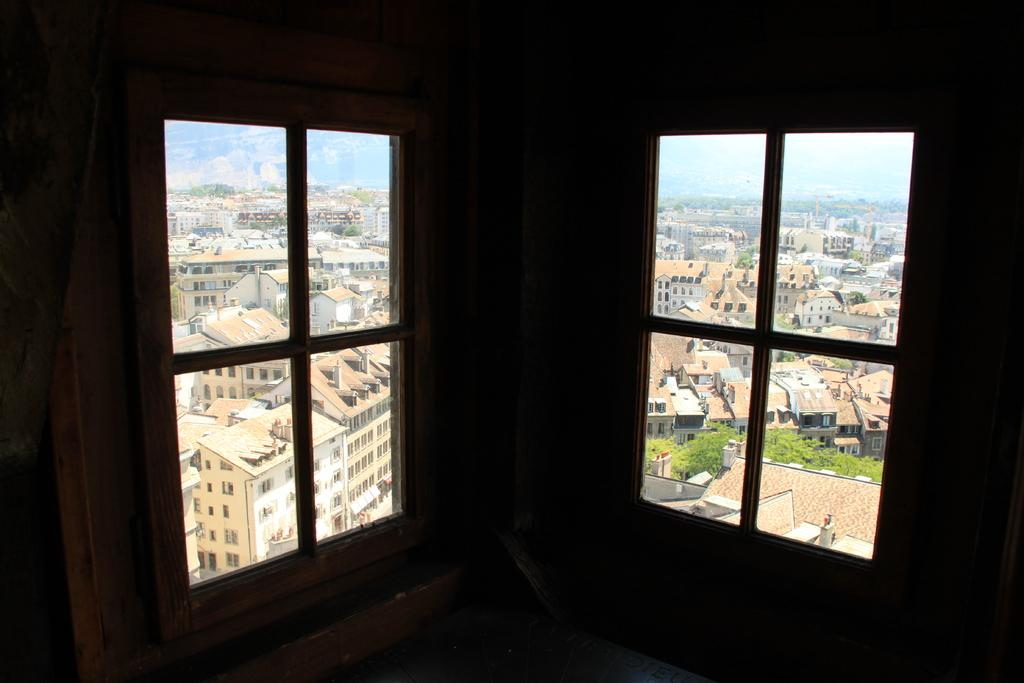What type of openings can be seen in the image? There are windows in the image. What structures are visible in the image? There are buildings in the image. What type of vegetation is present in the image? There are trees in the image. What part of the natural environment is visible in the image? The sky is visible in the image. From where might the image have been taken? The image may have been taken from a building. What type of curtain can be seen hanging from the windows in the image? There is no curtain visible in the image; only windows are present. How does the match contribute to the comfort of the buildings in the image? There is no match present in the image, and therefore it cannot contribute to the comfort of the buildings. 